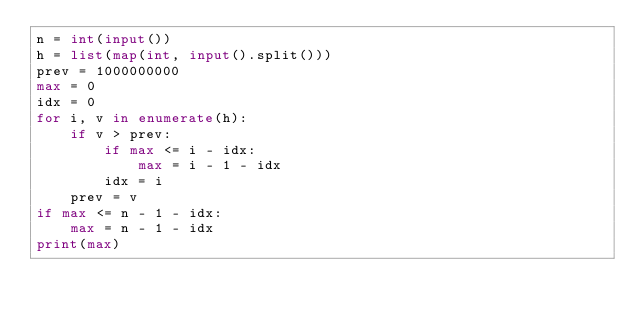<code> <loc_0><loc_0><loc_500><loc_500><_Python_>n = int(input())
h = list(map(int, input().split()))
prev = 1000000000
max = 0
idx = 0
for i, v in enumerate(h):
    if v > prev:
        if max <= i - idx:
            max = i - 1 - idx
        idx = i
    prev = v
if max <= n - 1 - idx:
    max = n - 1 - idx
print(max)
</code> 